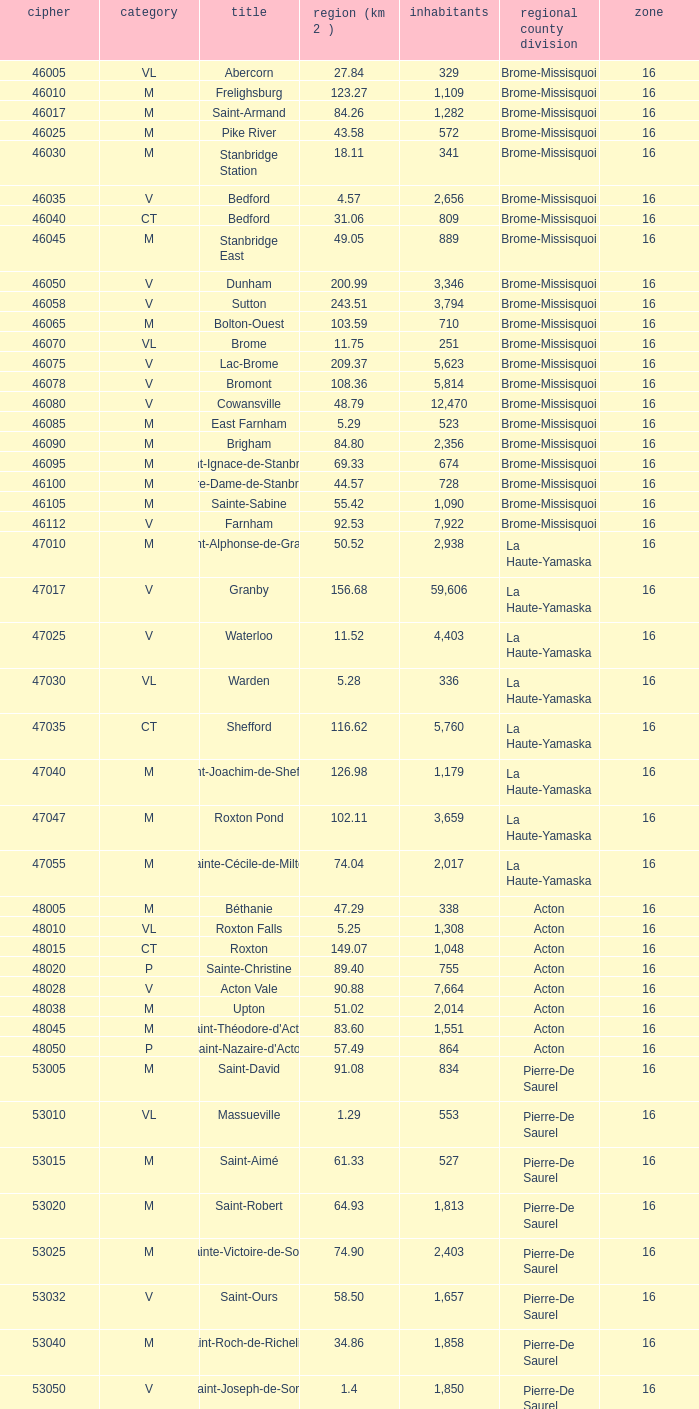Cowansville has less than 16 regions and is a Brome-Missisquoi Municipality, what is their population? None. 